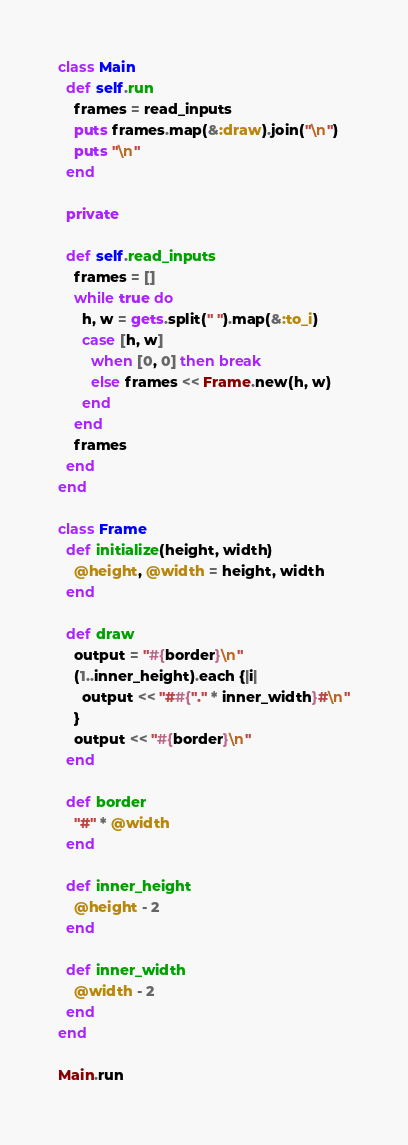Convert code to text. <code><loc_0><loc_0><loc_500><loc_500><_Ruby_>class Main
  def self.run
    frames = read_inputs
    puts frames.map(&:draw).join("\n")
    puts "\n"
  end

  private

  def self.read_inputs
    frames = []
    while true do
      h, w = gets.split(" ").map(&:to_i)
      case [h, w]
        when [0, 0] then break
        else frames << Frame.new(h, w)
      end
    end
    frames
  end
end

class Frame
  def initialize(height, width)
    @height, @width = height, width
  end

  def draw
    output = "#{border}\n"
    (1..inner_height).each {|i|
      output << "##{"." * inner_width}#\n"
    }
    output << "#{border}\n"
  end

  def border
    "#" * @width
  end

  def inner_height
    @height - 2
  end

  def inner_width
    @width - 2
  end
end

Main.run</code> 